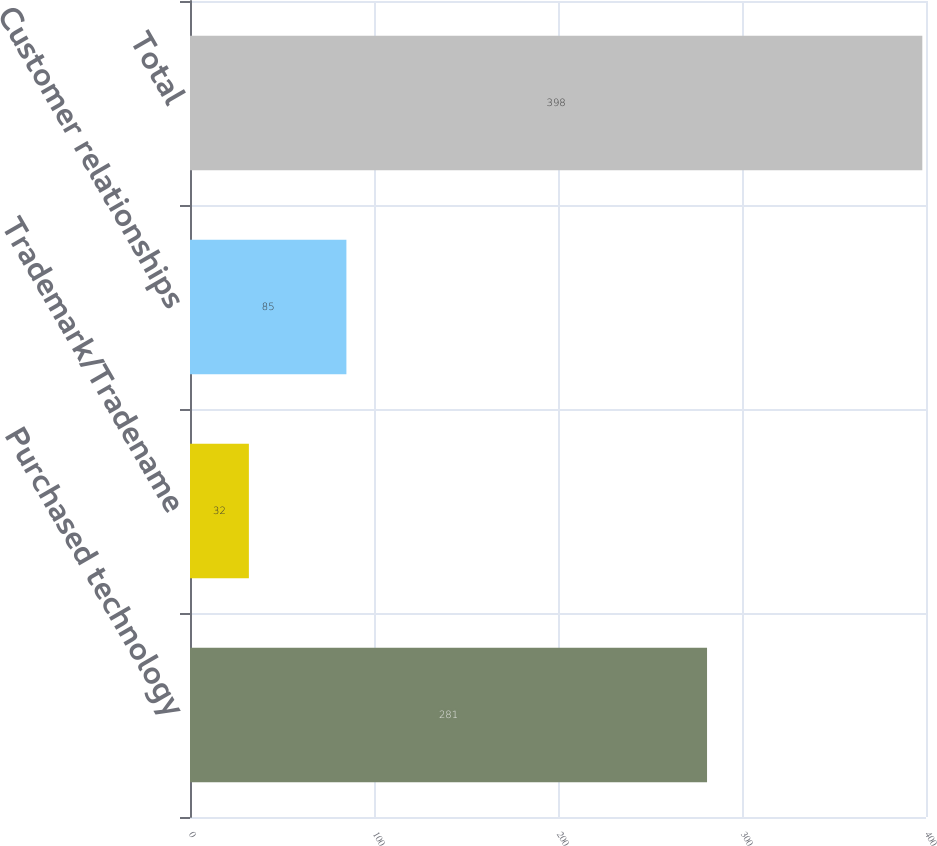Convert chart. <chart><loc_0><loc_0><loc_500><loc_500><bar_chart><fcel>Purchased technology<fcel>Trademark/Tradename<fcel>Customer relationships<fcel>Total<nl><fcel>281<fcel>32<fcel>85<fcel>398<nl></chart> 